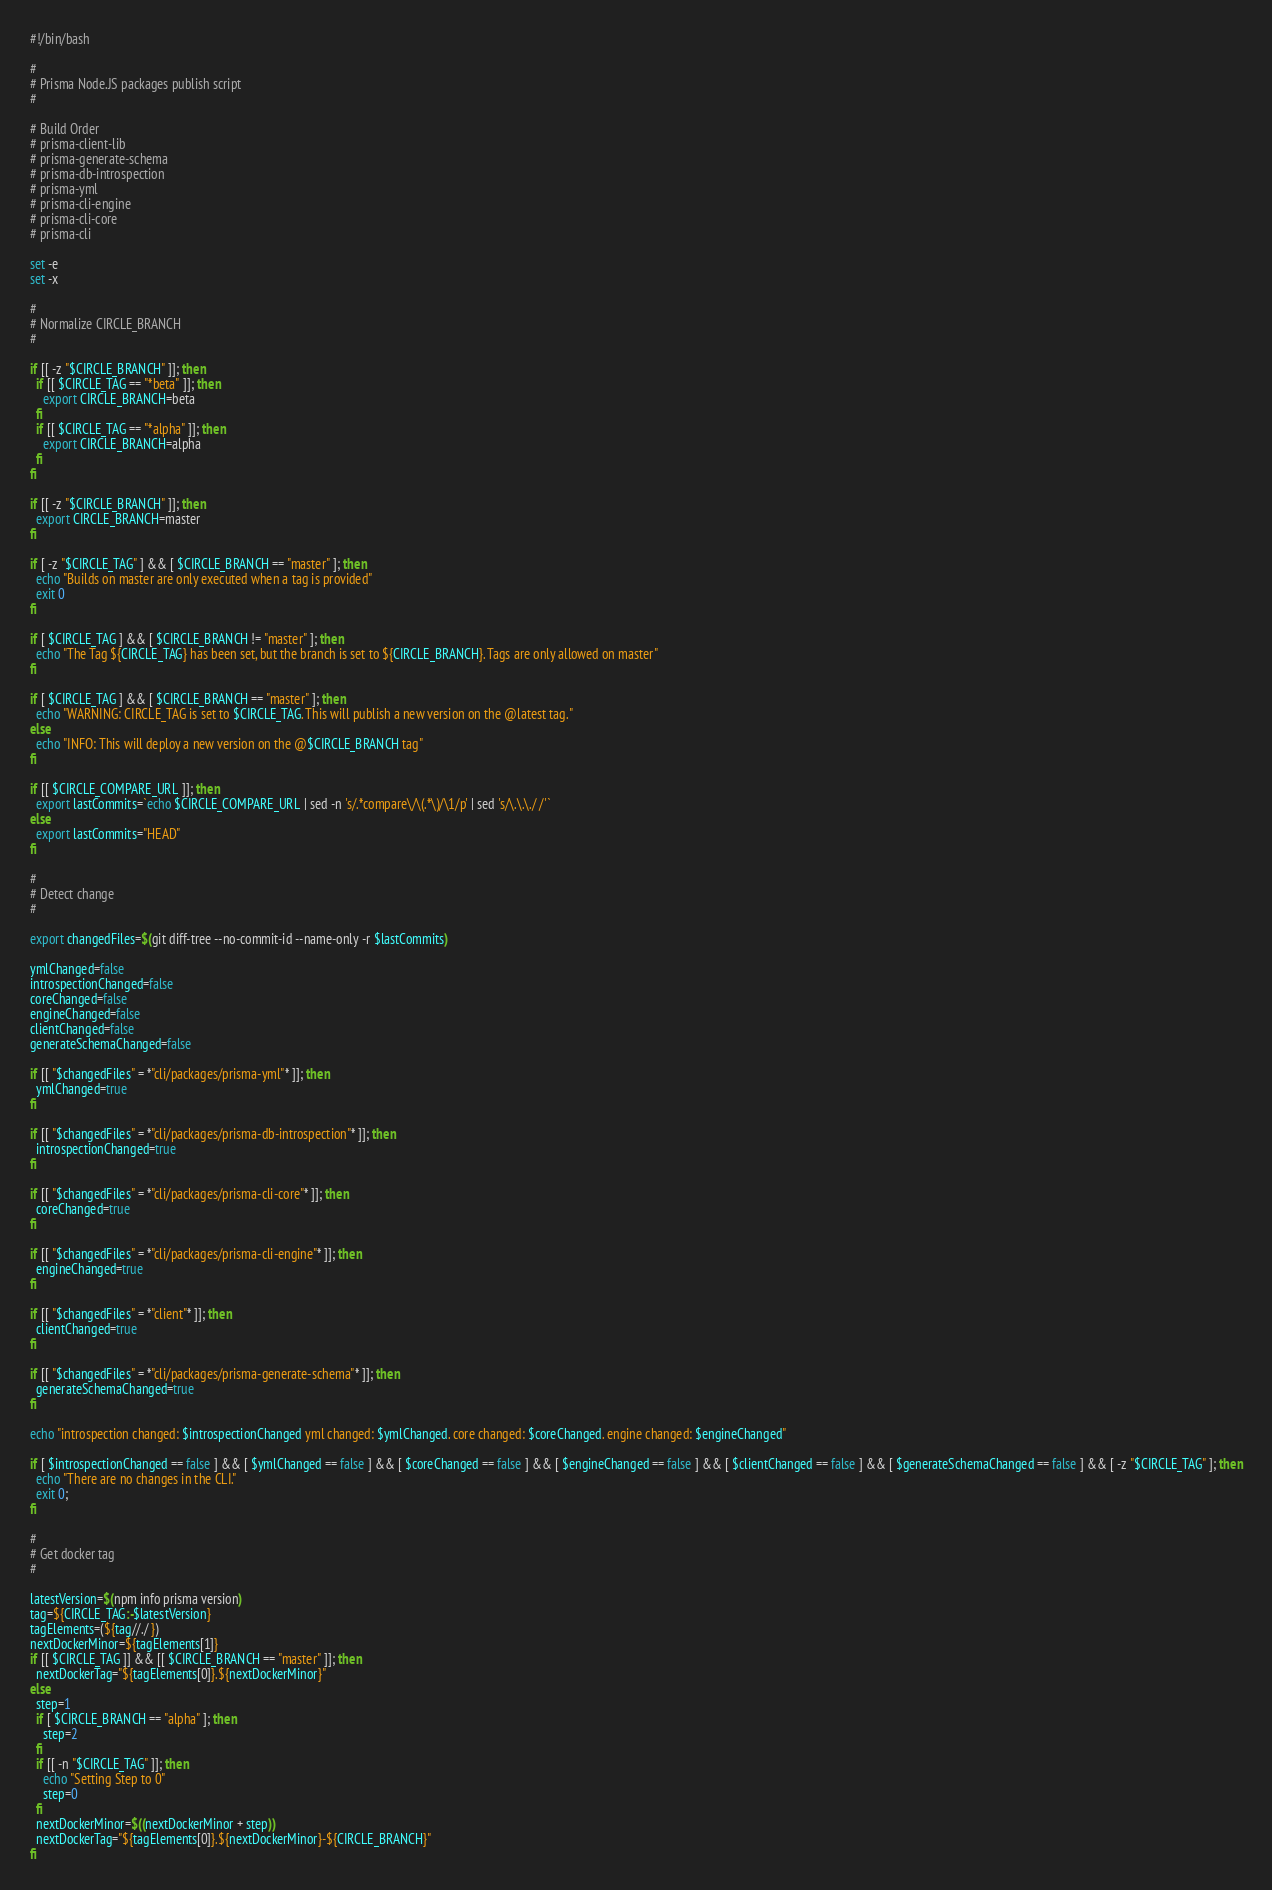<code> <loc_0><loc_0><loc_500><loc_500><_Bash_>#!/bin/bash

#
# Prisma Node.JS packages publish script
#

# Build Order
# prisma-client-lib
# prisma-generate-schema
# prisma-db-introspection
# prisma-yml
# prisma-cli-engine
# prisma-cli-core
# prisma-cli

set -e
set -x

#
# Normalize CIRCLE_BRANCH
#

if [[ -z "$CIRCLE_BRANCH" ]]; then
  if [[ $CIRCLE_TAG == "*beta" ]]; then
    export CIRCLE_BRANCH=beta
  fi
  if [[ $CIRCLE_TAG == "*alpha" ]]; then
    export CIRCLE_BRANCH=alpha
  fi
fi

if [[ -z "$CIRCLE_BRANCH" ]]; then
  export CIRCLE_BRANCH=master
fi

if [ -z "$CIRCLE_TAG" ] && [ $CIRCLE_BRANCH == "master" ]; then
  echo "Builds on master are only executed when a tag is provided"
  exit 0
fi

if [ $CIRCLE_TAG ] && [ $CIRCLE_BRANCH != "master" ]; then
  echo "The Tag ${CIRCLE_TAG} has been set, but the branch is set to ${CIRCLE_BRANCH}. Tags are only allowed on master"
fi

if [ $CIRCLE_TAG ] && [ $CIRCLE_BRANCH == "master" ]; then
  echo "WARNING: CIRCLE_TAG is set to $CIRCLE_TAG. This will publish a new version on the @latest tag."
else
  echo "INFO: This will deploy a new version on the @$CIRCLE_BRANCH tag"
fi

if [[ $CIRCLE_COMPARE_URL ]]; then
  export lastCommits=`echo $CIRCLE_COMPARE_URL | sed -n 's/.*compare\/\(.*\)/\1/p' | sed 's/\.\.\./ /'`
else
  export lastCommits="HEAD"
fi

#
# Detect change
#

export changedFiles=$(git diff-tree --no-commit-id --name-only -r $lastCommits)

ymlChanged=false
introspectionChanged=false
coreChanged=false
engineChanged=false
clientChanged=false
generateSchemaChanged=false

if [[ "$changedFiles" = *"cli/packages/prisma-yml"* ]]; then
  ymlChanged=true
fi

if [[ "$changedFiles" = *"cli/packages/prisma-db-introspection"* ]]; then
  introspectionChanged=true
fi

if [[ "$changedFiles" = *"cli/packages/prisma-cli-core"* ]]; then
  coreChanged=true
fi

if [[ "$changedFiles" = *"cli/packages/prisma-cli-engine"* ]]; then
  engineChanged=true
fi

if [[ "$changedFiles" = *"client"* ]]; then
  clientChanged=true
fi

if [[ "$changedFiles" = *"cli/packages/prisma-generate-schema"* ]]; then
  generateSchemaChanged=true
fi

echo "introspection changed: $introspectionChanged yml changed: $ymlChanged. core changed: $coreChanged. engine changed: $engineChanged"

if [ $introspectionChanged == false ] && [ $ymlChanged == false ] && [ $coreChanged == false ] && [ $engineChanged == false ] && [ $clientChanged == false ] && [ $generateSchemaChanged == false ] && [ -z "$CIRCLE_TAG" ]; then
  echo "There are no changes in the CLI."
  exit 0;
fi

#
# Get docker tag
#

latestVersion=$(npm info prisma version)
tag=${CIRCLE_TAG:-$latestVersion}
tagElements=(${tag//./ })
nextDockerMinor=${tagElements[1]}
if [[ $CIRCLE_TAG ]] && [[ $CIRCLE_BRANCH == "master" ]]; then
  nextDockerTag="${tagElements[0]}.${nextDockerMinor}"
else
  step=1
  if [ $CIRCLE_BRANCH == "alpha" ]; then
    step=2
  fi
  if [[ -n "$CIRCLE_TAG" ]]; then
    echo "Setting Step to 0"
    step=0
  fi
  nextDockerMinor=$((nextDockerMinor + step))
  nextDockerTag="${tagElements[0]}.${nextDockerMinor}-${CIRCLE_BRANCH}"
fi
</code> 